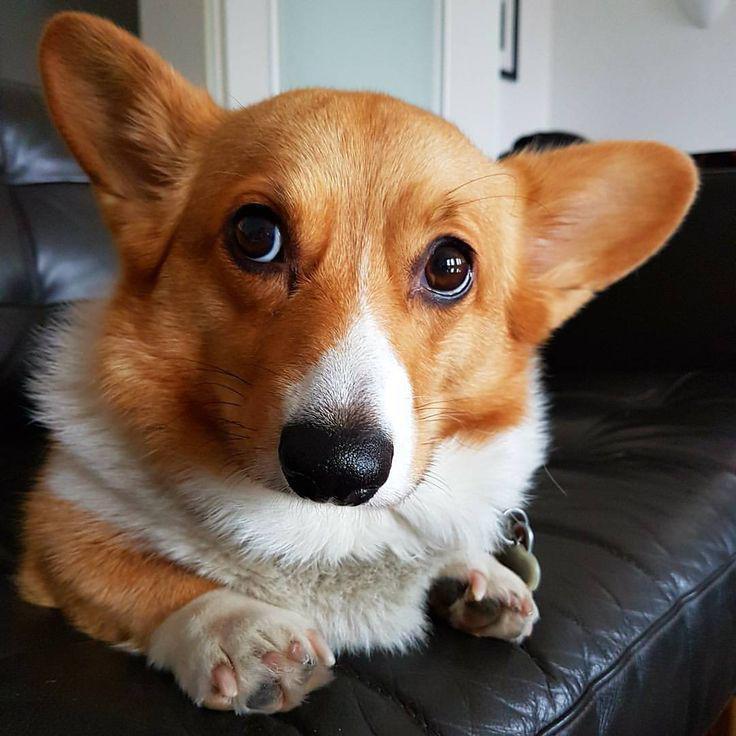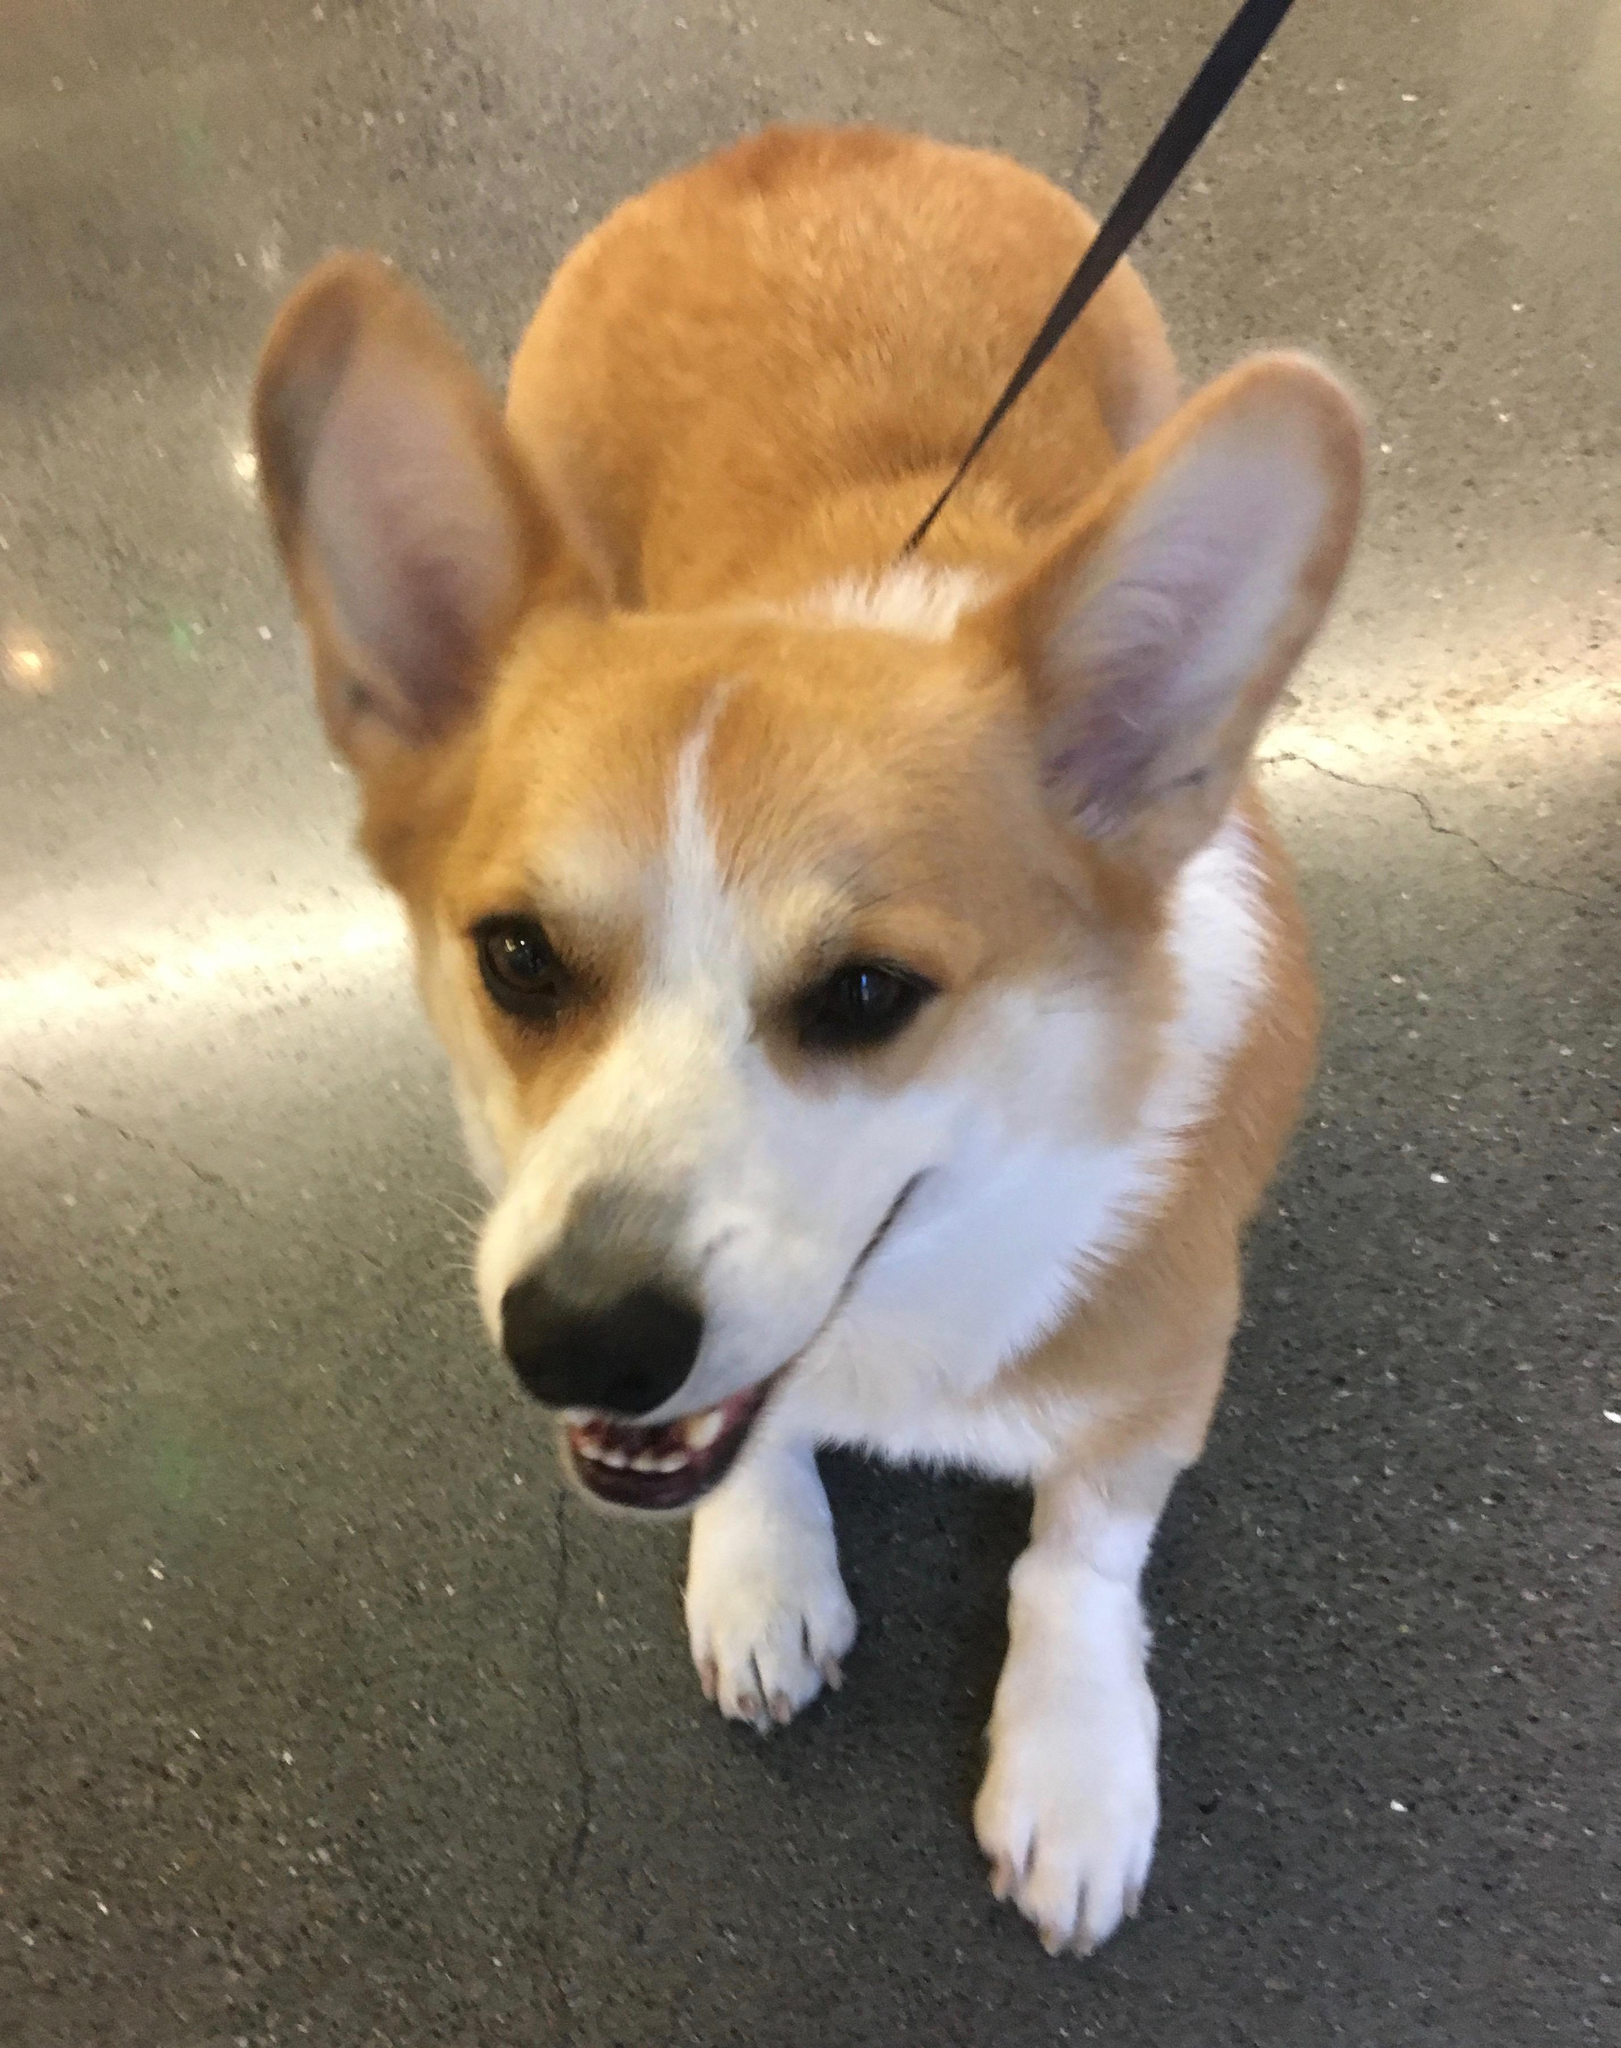The first image is the image on the left, the second image is the image on the right. Given the left and right images, does the statement "The dog in the image on the right is on a leasch" hold true? Answer yes or no. Yes. The first image is the image on the left, the second image is the image on the right. Given the left and right images, does the statement "There is one Corgi on a leash." hold true? Answer yes or no. Yes. 